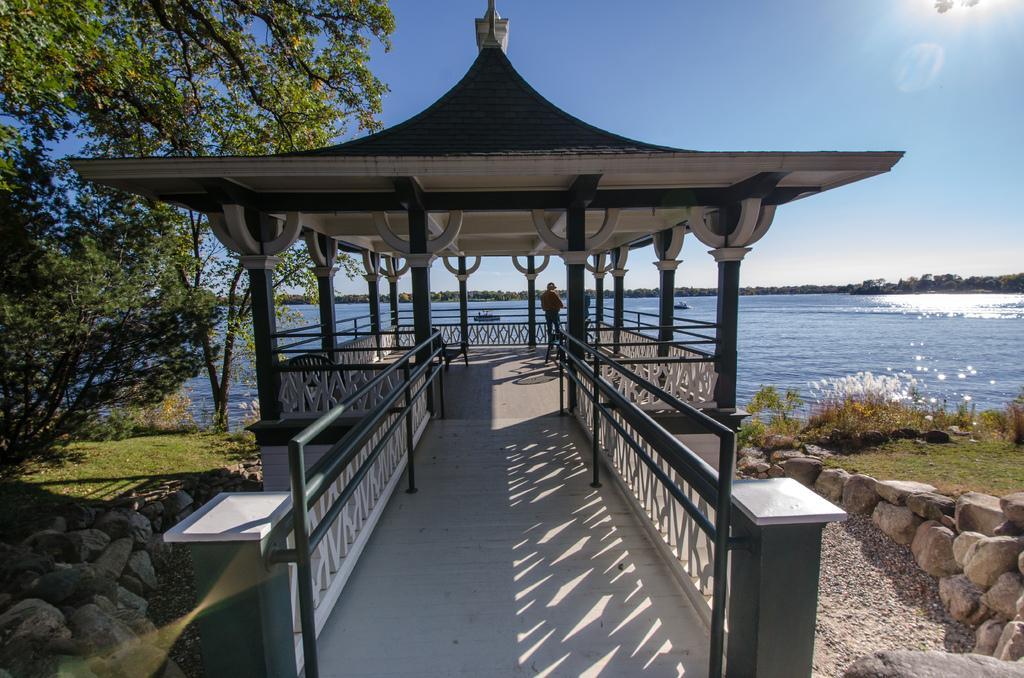Can you describe this image briefly? In this image, we can see the shed, there is a person standing under the shed, we can see some stones, there is grass on the ground, we can see a tree, there is a water, at the top there is a blue sky. 